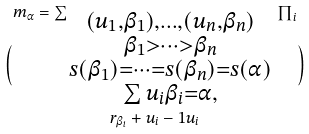Convert formula to latex. <formula><loc_0><loc_0><loc_500><loc_500>m _ { \alpha } = \sum _ { \begin{smallmatrix} ( u _ { 1 } , \beta _ { 1 } ) , \dots , ( u _ { n } , \beta _ { n } ) \\ \beta _ { 1 } > \dots > \beta _ { n } \\ s ( \beta _ { 1 } ) = \cdots = s ( \beta _ { n } ) = s ( \alpha ) \\ \sum u _ { i } \beta _ { i } = \alpha , \end{smallmatrix} } \prod _ { i } \choose { r _ { \beta _ { i } } + u _ { i } - 1 } { u _ { i } }</formula> 